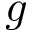Convert formula to latex. <formula><loc_0><loc_0><loc_500><loc_500>g</formula> 